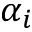Convert formula to latex. <formula><loc_0><loc_0><loc_500><loc_500>\alpha _ { i }</formula> 